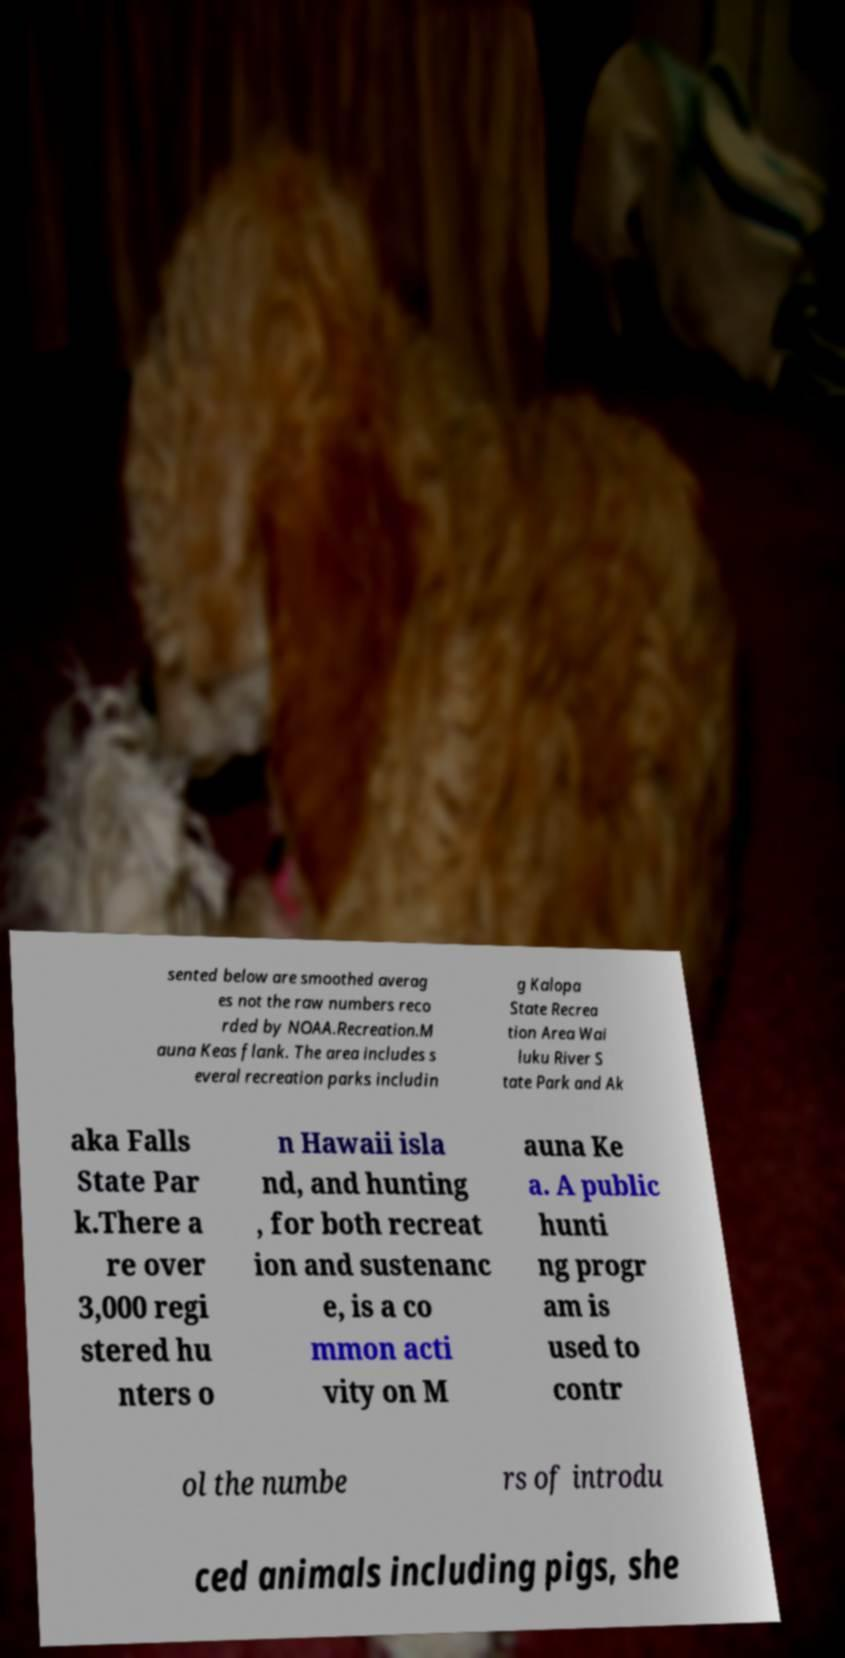Can you read and provide the text displayed in the image?This photo seems to have some interesting text. Can you extract and type it out for me? sented below are smoothed averag es not the raw numbers reco rded by NOAA.Recreation.M auna Keas flank. The area includes s everal recreation parks includin g Kalopa State Recrea tion Area Wai luku River S tate Park and Ak aka Falls State Par k.There a re over 3,000 regi stered hu nters o n Hawaii isla nd, and hunting , for both recreat ion and sustenanc e, is a co mmon acti vity on M auna Ke a. A public hunti ng progr am is used to contr ol the numbe rs of introdu ced animals including pigs, she 